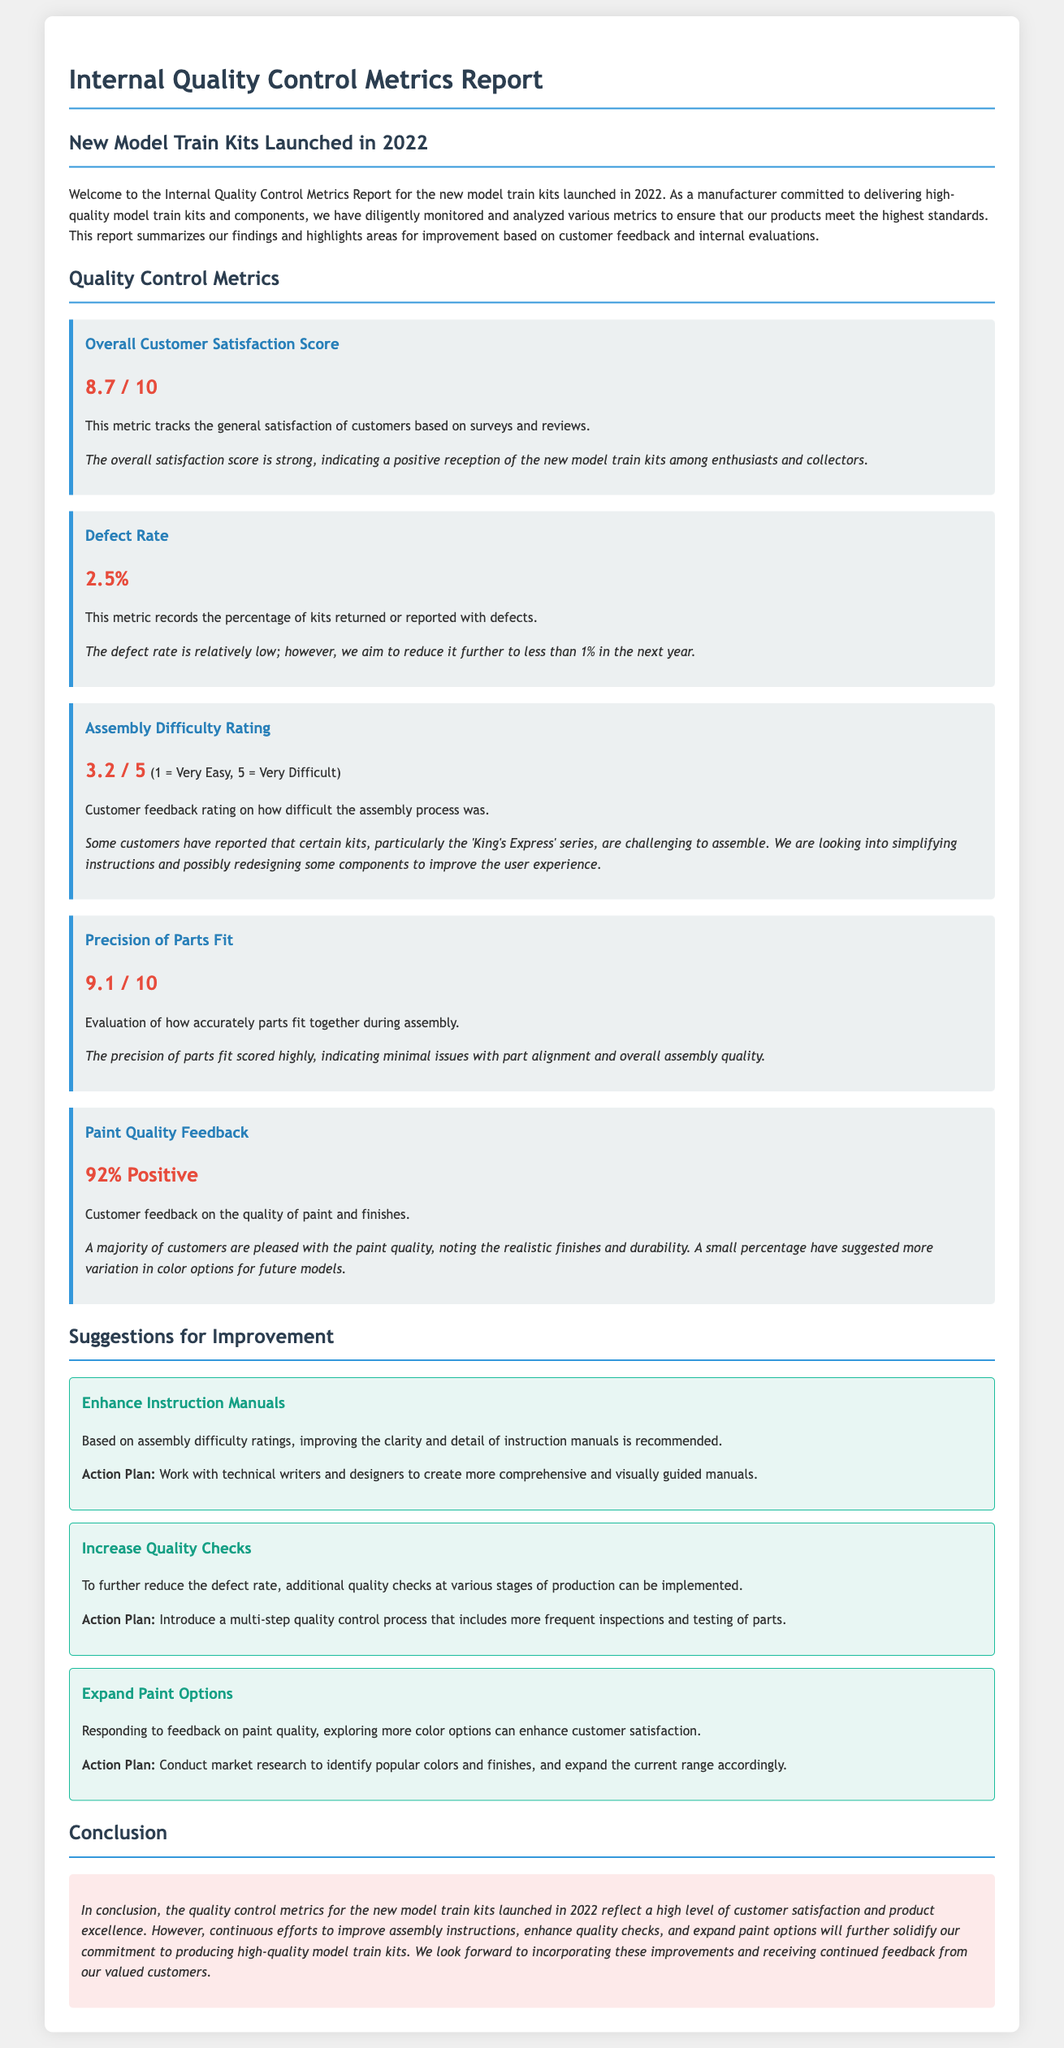What is the Overall Customer Satisfaction Score? The Overall Customer Satisfaction Score is determined based on general customer satisfaction from surveys and reviews.
Answer: 8.7 / 10 What is the Defect Rate reported in the document? The Defect Rate indicates the percentage of kits returned or reported with defects.
Answer: 2.5% What is the Assembly Difficulty Rating for the model train kits? The Assembly Difficulty Rating reflects customer feedback on how difficult the assembly process was rated on a scale.
Answer: 3.2 / 5 What percentage of customers gave positive feedback on Paint Quality? The Paint Quality Feedback summarizes customer opinions on the quality of paint and finishes.
Answer: 92% Positive What action is suggested to improve Instruction Manuals? The suggestion derives from assembly difficulty ratings, proposing to improve instructional clarity and detail.
Answer: More comprehensive manuals What is the recommended action to reduce the defect rate? To lessen the defect rate, the report suggests enhancing the frequency of quality checks during production.
Answer: Multi-step quality control process What specific kit is mentioned as being challenging to assemble? The report highlights customer feedback regarding difficulties in assembling certain kits.
Answer: 'King's Express' series What is the conclusion regarding the quality control metrics? The conclusion summarizes the results and indicates areas for improvement based on customer feedback.
Answer: High level of customer satisfaction How will feedback from customers be used in future improvements? The report concludes by indicating that customer feedback will guide enhancements in product quality and features.
Answer: Incorporating improvements 